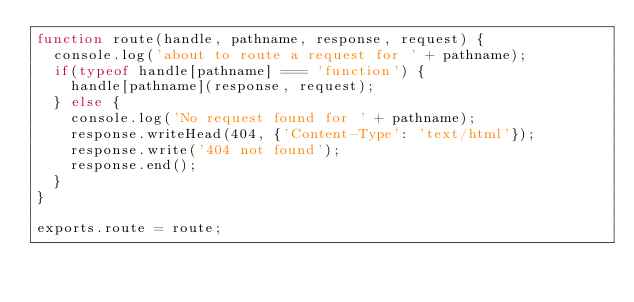<code> <loc_0><loc_0><loc_500><loc_500><_JavaScript_>function route(handle, pathname, response, request) {
  console.log('about to route a request for ' + pathname);
  if(typeof handle[pathname] === 'function') {
    handle[pathname](response, request);
  } else {
    console.log('No request found for ' + pathname);
    response.writeHead(404, {'Content-Type': 'text/html'});
    response.write('404 not found');
    response.end();
  }
}

exports.route = route;
</code> 